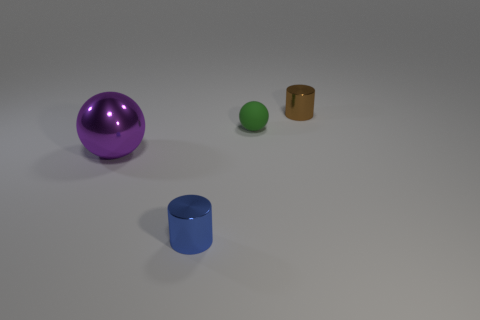Are there any other things that are the same size as the purple ball?
Your answer should be compact. No. Does the green object have the same material as the purple object?
Your response must be concise. No. What shape is the metallic thing that is to the left of the tiny shiny thing that is to the left of the brown cylinder that is to the right of the large purple metal ball?
Your answer should be very brief. Sphere. Are there fewer tiny rubber objects in front of the green sphere than blue metal objects right of the tiny blue shiny cylinder?
Offer a very short reply. No. What is the shape of the tiny metallic object left of the small object that is behind the green rubber object?
Keep it short and to the point. Cylinder. Is there anything else of the same color as the matte object?
Provide a succinct answer. No. Does the large metal object have the same color as the small rubber object?
Ensure brevity in your answer.  No. What number of cyan things are matte objects or large metal cubes?
Offer a terse response. 0. Is the number of matte spheres on the left side of the metallic ball less than the number of purple shiny objects?
Provide a short and direct response. Yes. There is a tiny shiny cylinder in front of the small matte ball; how many blue metal cylinders are to the right of it?
Keep it short and to the point. 0. 